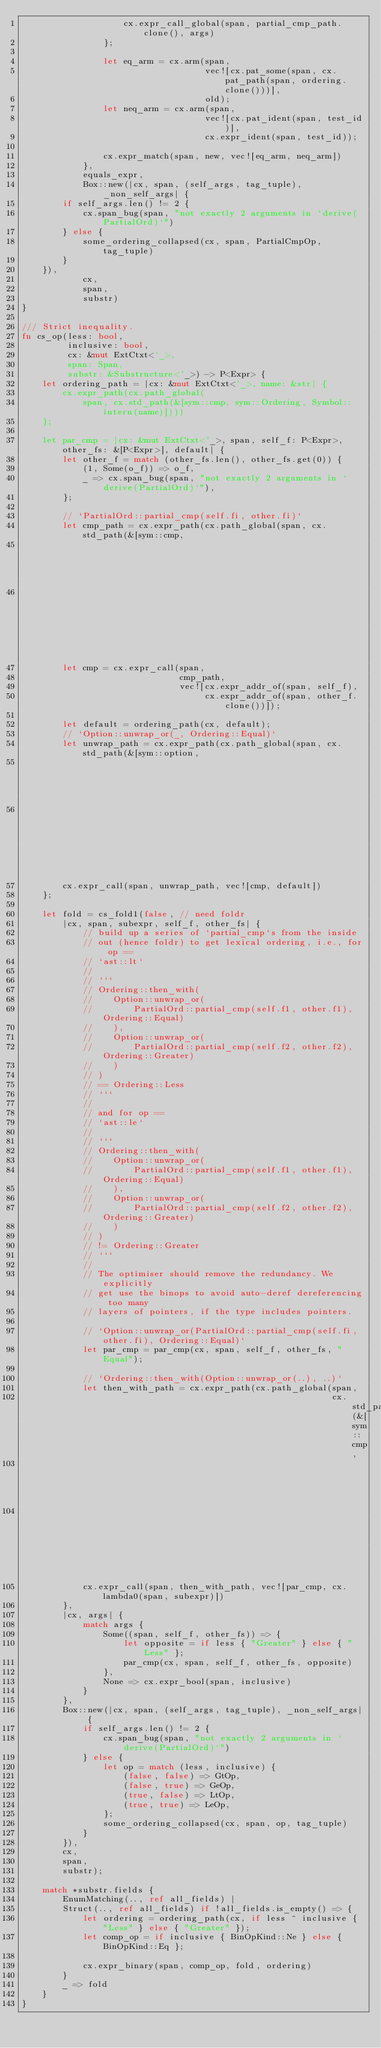<code> <loc_0><loc_0><loc_500><loc_500><_Rust_>                    cx.expr_call_global(span, partial_cmp_path.clone(), args)
                };

                let eq_arm = cx.arm(span,
                                    vec![cx.pat_some(span, cx.pat_path(span, ordering.clone()))],
                                    old);
                let neq_arm = cx.arm(span,
                                    vec![cx.pat_ident(span, test_id)],
                                    cx.expr_ident(span, test_id));

                cx.expr_match(span, new, vec![eq_arm, neq_arm])
            },
            equals_expr,
            Box::new(|cx, span, (self_args, tag_tuple), _non_self_args| {
        if self_args.len() != 2 {
            cx.span_bug(span, "not exactly 2 arguments in `derive(PartialOrd)`")
        } else {
            some_ordering_collapsed(cx, span, PartialCmpOp, tag_tuple)
        }
    }),
            cx,
            span,
            substr)
}

/// Strict inequality.
fn cs_op(less: bool,
         inclusive: bool,
         cx: &mut ExtCtxt<'_>,
         span: Span,
         substr: &Substructure<'_>) -> P<Expr> {
    let ordering_path = |cx: &mut ExtCtxt<'_>, name: &str| {
        cx.expr_path(cx.path_global(
            span, cx.std_path(&[sym::cmp, sym::Ordering, Symbol::intern(name)])))
    };

    let par_cmp = |cx: &mut ExtCtxt<'_>, span, self_f: P<Expr>, other_fs: &[P<Expr>], default| {
        let other_f = match (other_fs.len(), other_fs.get(0)) {
            (1, Some(o_f)) => o_f,
            _ => cx.span_bug(span, "not exactly 2 arguments in `derive(PartialOrd)`"),
        };

        // `PartialOrd::partial_cmp(self.fi, other.fi)`
        let cmp_path = cx.expr_path(cx.path_global(span, cx.std_path(&[sym::cmp,
                                                                       sym::PartialOrd,
                                                                       sym::partial_cmp])));
        let cmp = cx.expr_call(span,
                               cmp_path,
                               vec![cx.expr_addr_of(span, self_f),
                                    cx.expr_addr_of(span, other_f.clone())]);

        let default = ordering_path(cx, default);
        // `Option::unwrap_or(_, Ordering::Equal)`
        let unwrap_path = cx.expr_path(cx.path_global(span, cx.std_path(&[sym::option,
                                                                          sym::Option,
                                                                          sym::unwrap_or])));
        cx.expr_call(span, unwrap_path, vec![cmp, default])
    };

    let fold = cs_fold1(false, // need foldr
        |cx, span, subexpr, self_f, other_fs| {
            // build up a series of `partial_cmp`s from the inside
            // out (hence foldr) to get lexical ordering, i.e., for op ==
            // `ast::lt`
            //
            // ```
            // Ordering::then_with(
            //    Option::unwrap_or(
            //        PartialOrd::partial_cmp(self.f1, other.f1), Ordering::Equal)
            //    ),
            //    Option::unwrap_or(
            //        PartialOrd::partial_cmp(self.f2, other.f2), Ordering::Greater)
            //    )
            // )
            // == Ordering::Less
            // ```
            //
            // and for op ==
            // `ast::le`
            //
            // ```
            // Ordering::then_with(
            //    Option::unwrap_or(
            //        PartialOrd::partial_cmp(self.f1, other.f1), Ordering::Equal)
            //    ),
            //    Option::unwrap_or(
            //        PartialOrd::partial_cmp(self.f2, other.f2), Ordering::Greater)
            //    )
            // )
            // != Ordering::Greater
            // ```
            //
            // The optimiser should remove the redundancy. We explicitly
            // get use the binops to avoid auto-deref dereferencing too many
            // layers of pointers, if the type includes pointers.

            // `Option::unwrap_or(PartialOrd::partial_cmp(self.fi, other.fi), Ordering::Equal)`
            let par_cmp = par_cmp(cx, span, self_f, other_fs, "Equal");

            // `Ordering::then_with(Option::unwrap_or(..), ..)`
            let then_with_path = cx.expr_path(cx.path_global(span,
                                                             cx.std_path(&[sym::cmp,
                                                                           sym::Ordering,
                                                                           sym::then_with])));
            cx.expr_call(span, then_with_path, vec![par_cmp, cx.lambda0(span, subexpr)])
        },
        |cx, args| {
            match args {
                Some((span, self_f, other_fs)) => {
                    let opposite = if less { "Greater" } else { "Less" };
                    par_cmp(cx, span, self_f, other_fs, opposite)
                },
                None => cx.expr_bool(span, inclusive)
            }
        },
        Box::new(|cx, span, (self_args, tag_tuple), _non_self_args| {
            if self_args.len() != 2 {
                cx.span_bug(span, "not exactly 2 arguments in `derive(PartialOrd)`")
            } else {
                let op = match (less, inclusive) {
                    (false, false) => GtOp,
                    (false, true) => GeOp,
                    (true, false) => LtOp,
                    (true, true) => LeOp,
                };
                some_ordering_collapsed(cx, span, op, tag_tuple)
            }
        }),
        cx,
        span,
        substr);

    match *substr.fields {
        EnumMatching(.., ref all_fields) |
        Struct(.., ref all_fields) if !all_fields.is_empty() => {
            let ordering = ordering_path(cx, if less ^ inclusive { "Less" } else { "Greater" });
            let comp_op = if inclusive { BinOpKind::Ne } else { BinOpKind::Eq };

            cx.expr_binary(span, comp_op, fold, ordering)
        }
        _ => fold
    }
}
</code> 